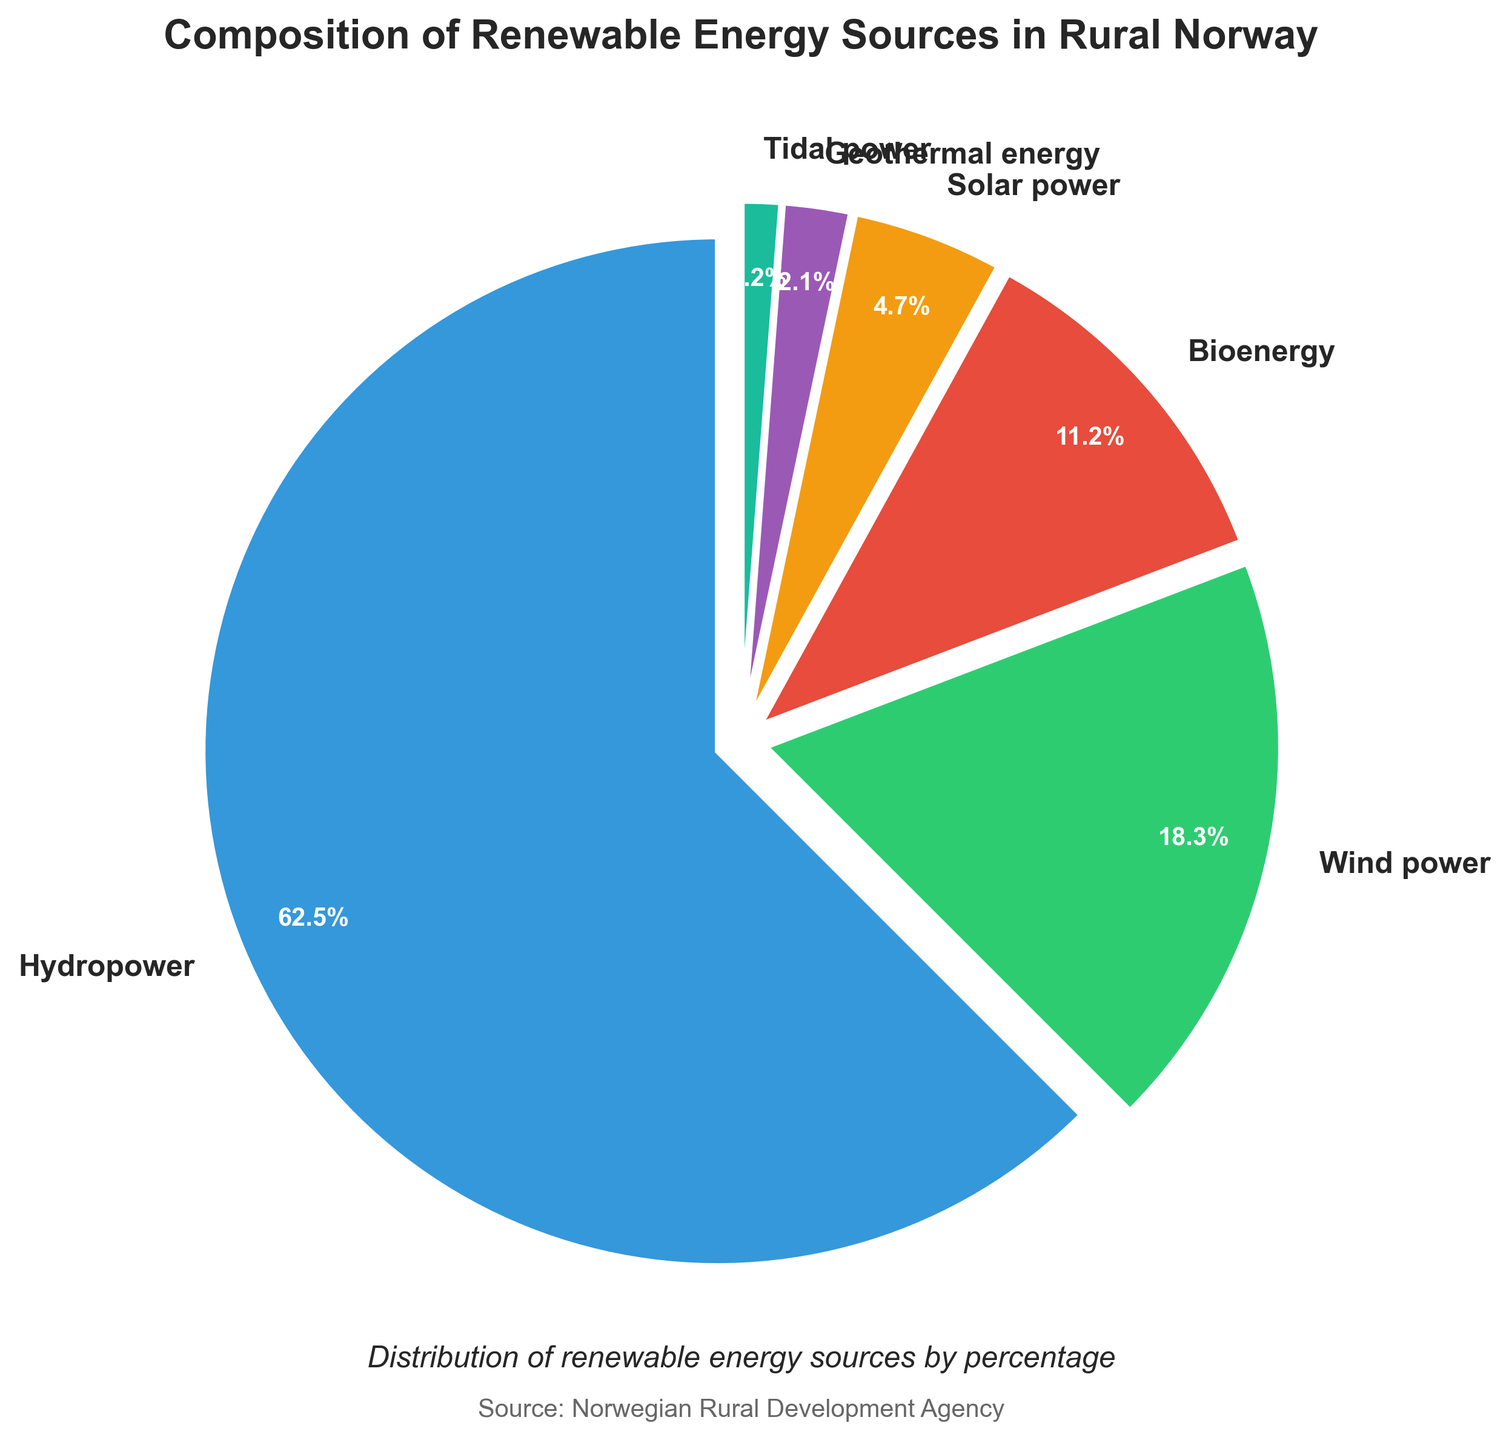What is the most significant source of renewable energy in rural Norway according to the figure? The figure shows multiple sources of renewable energy with their corresponding percentages. Hydropower occupies the largest portion of the pie chart with 62.5%, making it the most significant source.
Answer: Hydropower What is the sum of the percentages for wind power and solar power? The figure provides separate percentages for wind power (18.3%) and solar power (4.7%). Adding them together: 18.3% + 4.7% = 23.0%.
Answer: 23.0% Which energy source has the smallest representation, and what is its percentage? By looking at the figure, we can see that tidal power has the smallest segment among all the sources. Its percentage is 1.2%.
Answer: Tidal power, 1.2% How does the percentage of bioenergy compare to that of geothermal energy? The figure shows that bioenergy has a percentage of 11.2% and geothermal energy has 2.1%. Comparing these, bioenergy has a higher percentage than geothermal energy.
Answer: Bioenergy has a higher percentage What is the combined percentage of all renewable energy sources excluding hydropower? The figure lists the percentages for hydropower (62.5%), wind power (18.3%), bioenergy (11.2%), solar power (4.7%), geothermal energy (2.1%), and tidal power (1.2%). Adding the percentages of all sources except hydropower: 18.3% + 11.2% + 4.7% + 2.1% + 1.2% = 37.5%.
Answer: 37.5% Is the percentage of wind power more than double the percentage of bioenergy? The figure shows that the percentage of wind power is 18.3% and bioenergy is 11.2%. Double of bioenergy percentage is 11.2% * 2 = 22.4%. Since 18.3% < 22.4%, wind power is not more than double the percentage of bioenergy.
Answer: No What is the difference in percentage between the largest and smallest renewable energy sources? According to the figure, the largest energy source is hydropower at 62.5%, and the smallest is tidal power at 1.2%. The difference is calculated as 62.5% - 1.2% = 61.3%.
Answer: 61.3% What is the average percentage of all the renewable energy sources? The figure has six energy sources with the following percentages: 62.5%, 18.3%, 11.2%, 4.7%, 2.1%, and 1.2%. To find the average, sum these percentages and divide by the number of sources: (62.5 + 18.3 + 11.2 + 4.7 + 2.1 + 1.2) / 6 ≈ 16.67%.
Answer: Approximately 16.67% If you combine the percentages of solar power and tidal power, does it exceed that of bioenergy? The figure shows solar power at 4.7% and tidal power at 1.2%. Combining these: 4.7% + 1.2% = 5.9%. Comparing this to bioenergy at 11.2%, 5.9% is less than 11.2%, so it does not exceed bioenergy.
Answer: No Which energy sources have a combined percentage greater than 20%? Based on the figure, hydropower has 62.5%, wind power has 18.3%, bioenergy has 11.2%, solar power has 4.7%, geothermal energy has 2.1%, and tidal power has 1.2%. Combining hydropower alone already exceeds 20%. Wind power and bioenergy together also exceed 20%: 18.3% + 11.2% = 29.5%. Therefore, hydropower and wind power + bioenergy have combined percentages greater than 20%.
Answer: Hydropower, wind power + bioenergy 